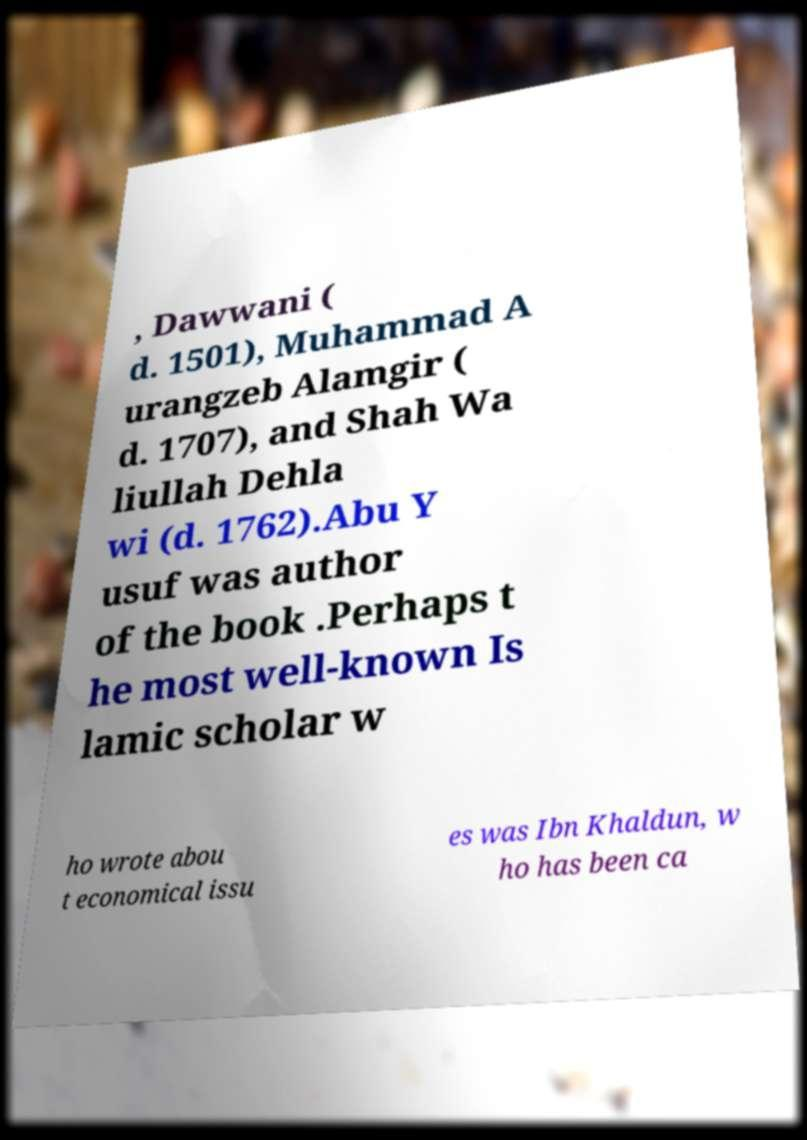Could you assist in decoding the text presented in this image and type it out clearly? , Dawwani ( d. 1501), Muhammad A urangzeb Alamgir ( d. 1707), and Shah Wa liullah Dehla wi (d. 1762).Abu Y usuf was author of the book .Perhaps t he most well-known Is lamic scholar w ho wrote abou t economical issu es was Ibn Khaldun, w ho has been ca 